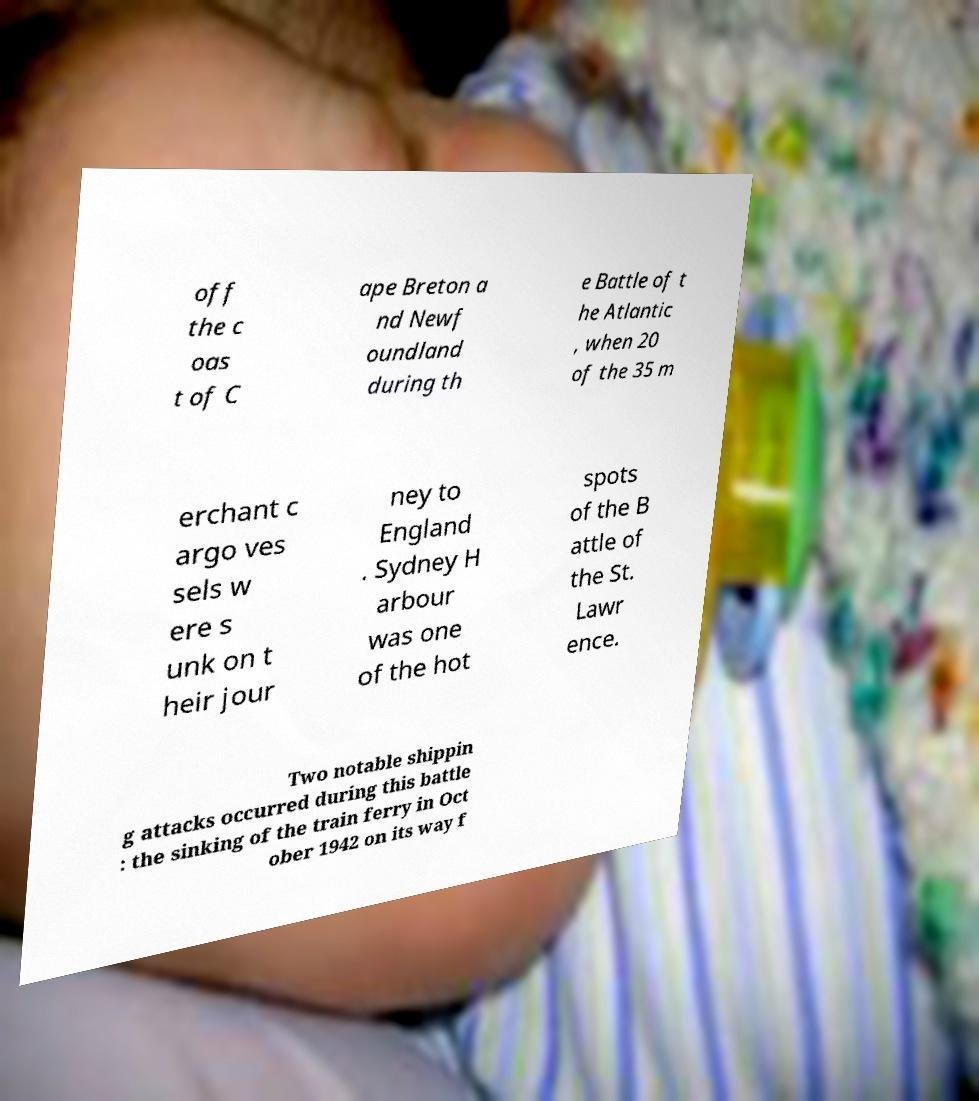There's text embedded in this image that I need extracted. Can you transcribe it verbatim? off the c oas t of C ape Breton a nd Newf oundland during th e Battle of t he Atlantic , when 20 of the 35 m erchant c argo ves sels w ere s unk on t heir jour ney to England . Sydney H arbour was one of the hot spots of the B attle of the St. Lawr ence. Two notable shippin g attacks occurred during this battle : the sinking of the train ferry in Oct ober 1942 on its way f 